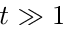Convert formula to latex. <formula><loc_0><loc_0><loc_500><loc_500>t \gg 1</formula> 